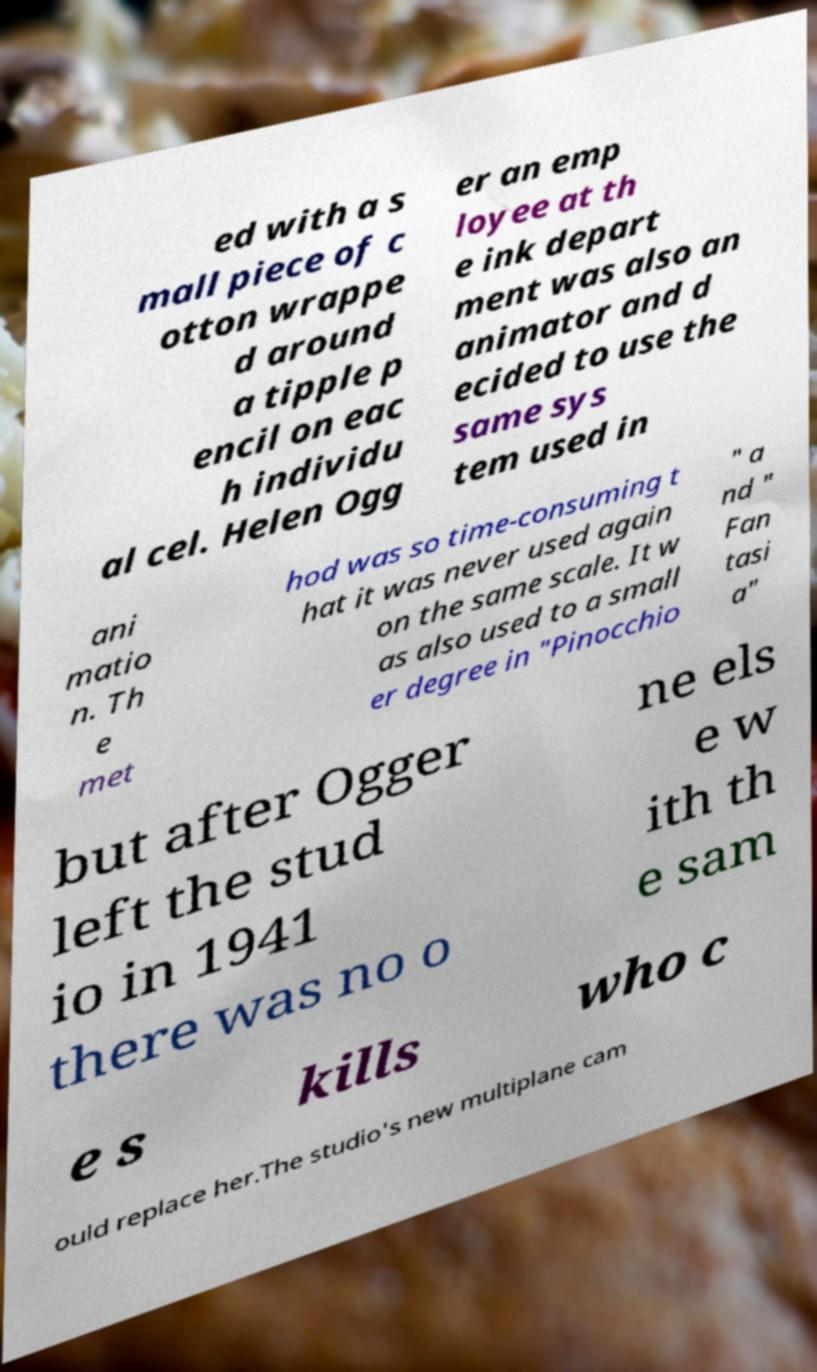Can you accurately transcribe the text from the provided image for me? ed with a s mall piece of c otton wrappe d around a tipple p encil on eac h individu al cel. Helen Ogg er an emp loyee at th e ink depart ment was also an animator and d ecided to use the same sys tem used in ani matio n. Th e met hod was so time-consuming t hat it was never used again on the same scale. It w as also used to a small er degree in "Pinocchio " a nd " Fan tasi a" but after Ogger left the stud io in 1941 there was no o ne els e w ith th e sam e s kills who c ould replace her.The studio's new multiplane cam 